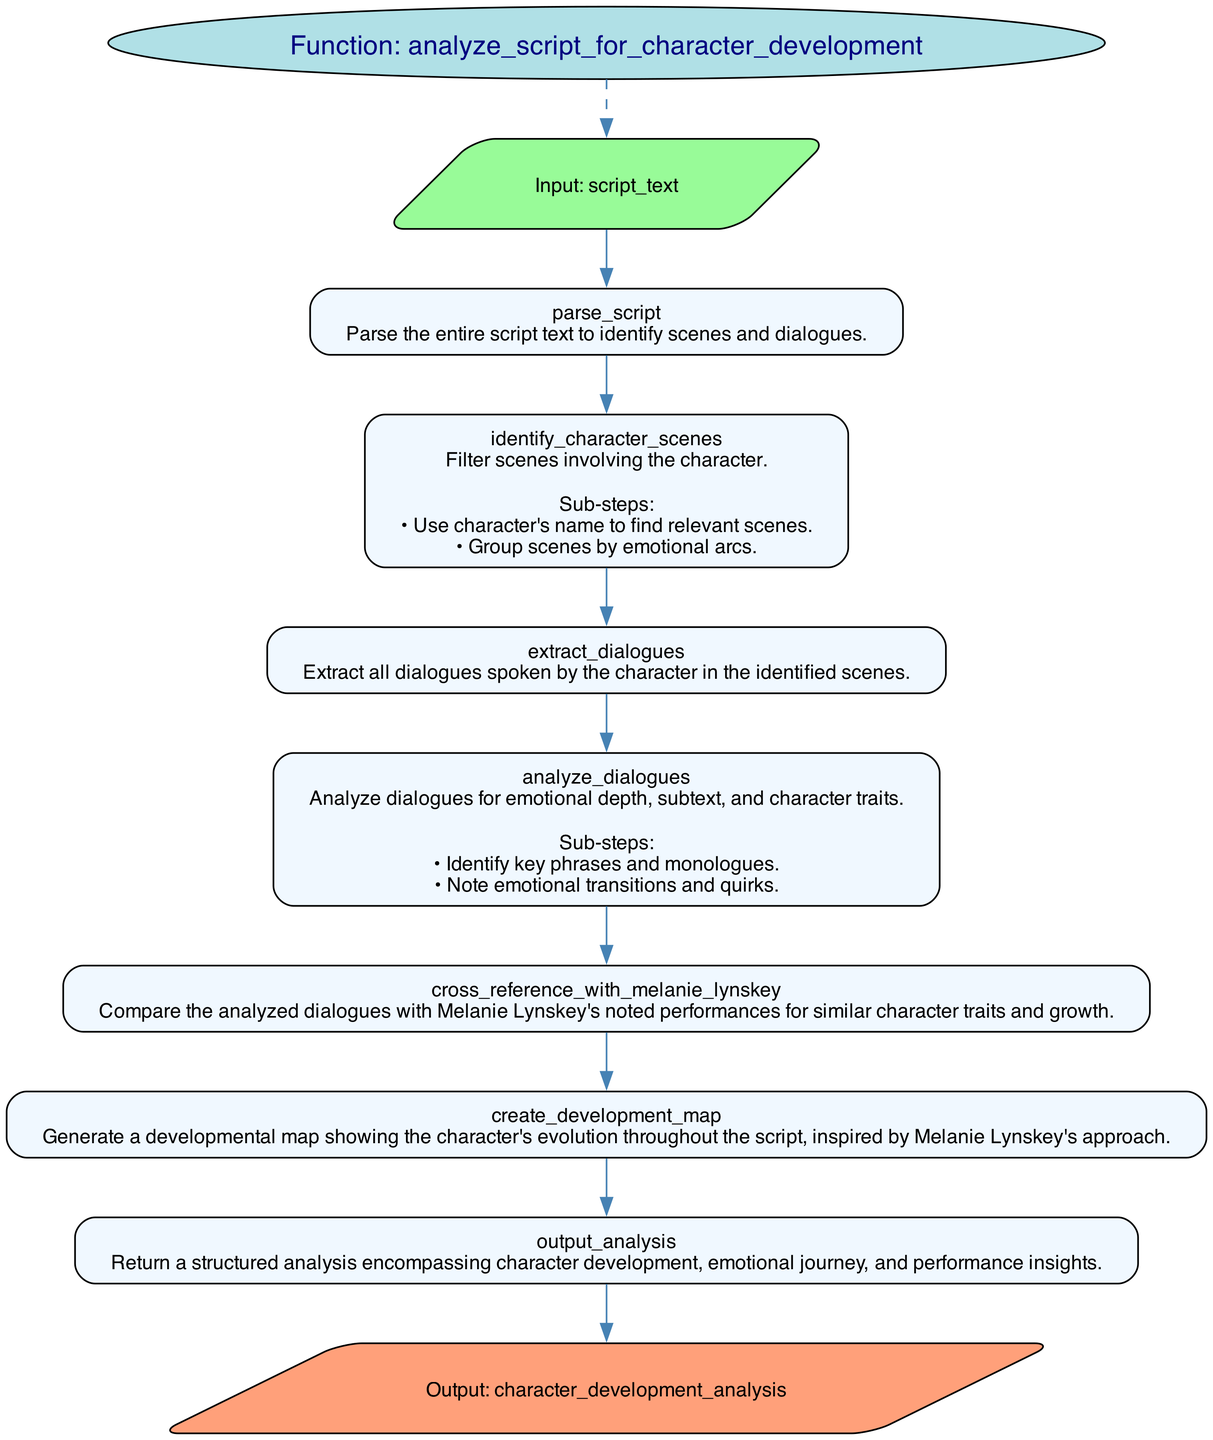What is the function name in the diagram? The diagram clearly labels the function name as "analyze_script_for_character_development" in an ellipse at the top.
Answer: analyze_script_for_character_development How many inputs does the function have? The diagram lists one input, which is "script_text" shown in a parallelogram shape under the function name. Therefore, the count of inputs is one.
Answer: 1 What is the operation of the first step? The first step outlined in the diagram is "parse_script," and this is prominently displayed as the first rectangle under the inputs.
Answer: parse_script Which step involves analyzing dialogues? The step that specifically mentions analyzing dialogues is labeled "analyze_dialogues," which is the fourth step in the flowchart, located lower in the sequence.
Answer: analyze_dialogues How many sub-steps are listed in the "identify_character_scenes" operation? In the "identify_character_scenes" step, there are two sub-steps provided in the details, which can be identified below the main description in the rectangle.
Answer: 2 Which step comes before "cross_reference_with_melanie_lynskey"? The step that comes directly before "cross_reference_with_melanie_lynskey" is "analyze_dialogues," as seen when tracing the flow from one rectangle to the next.
Answer: analyze_dialogues What is the output of the function? The output of the function is specified as "character_development_analysis" in the parallelogram at the bottom of the diagram, indicating the result of the process.
Answer: character_development_analysis In the flowchart, how many total steps are there? By counting the steps listed between the input and output nodes in the diagram, there are a total of seven steps.
Answer: 7 What is the relationship between the "input" and the first step? The relationship is indicated by a directed edge from the "input" node to the first step "parse_script," which illustrates the flow from input to processing.
Answer: Directed edge 